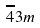Convert formula to latex. <formula><loc_0><loc_0><loc_500><loc_500>\overline { 4 } 3 m</formula> 